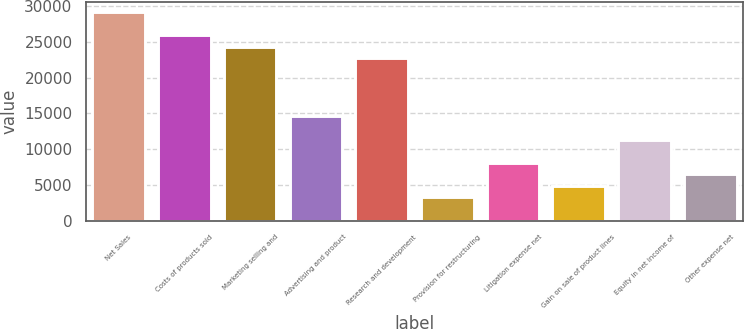Convert chart to OTSL. <chart><loc_0><loc_0><loc_500><loc_500><bar_chart><fcel>Net Sales<fcel>Costs of products sold<fcel>Marketing selling and<fcel>Advertising and product<fcel>Research and development<fcel>Provision for restructuring<fcel>Litigation expense net<fcel>Gain on sale of product lines<fcel>Equity in net income of<fcel>Other expense net<nl><fcel>29173.8<fcel>25932.3<fcel>24311.6<fcel>14587.3<fcel>22690.9<fcel>3242.25<fcel>8104.41<fcel>4862.97<fcel>11345.9<fcel>6483.69<nl></chart> 